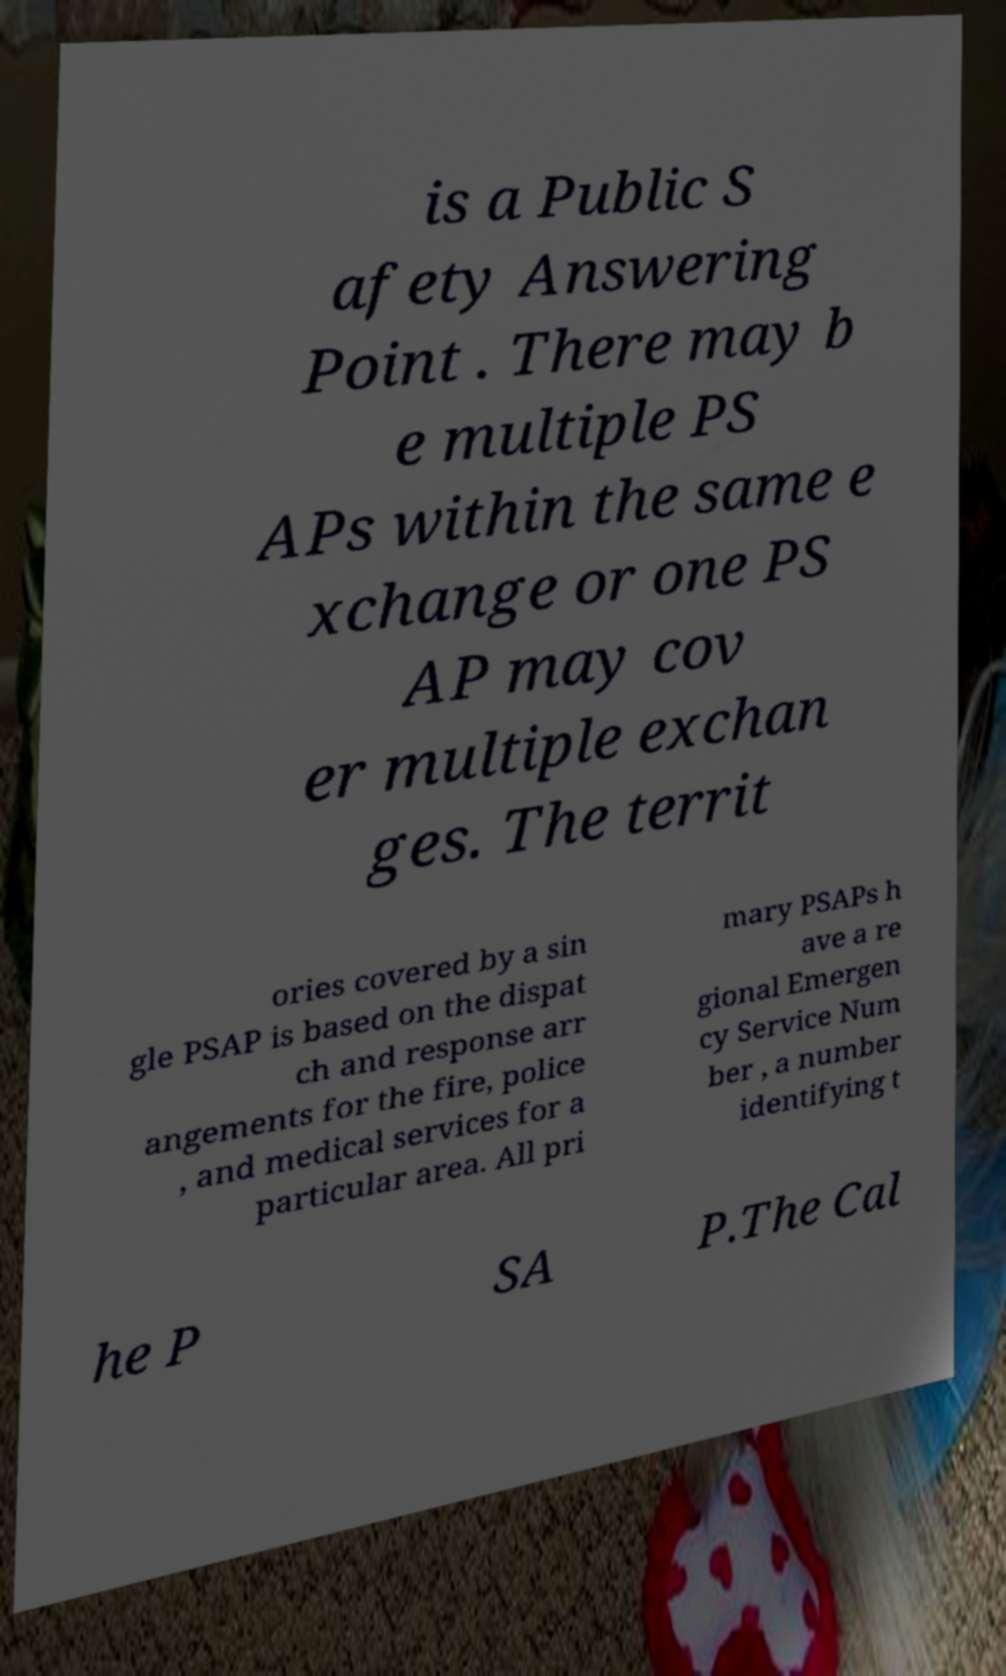For documentation purposes, I need the text within this image transcribed. Could you provide that? is a Public S afety Answering Point . There may b e multiple PS APs within the same e xchange or one PS AP may cov er multiple exchan ges. The territ ories covered by a sin gle PSAP is based on the dispat ch and response arr angements for the fire, police , and medical services for a particular area. All pri mary PSAPs h ave a re gional Emergen cy Service Num ber , a number identifying t he P SA P.The Cal 